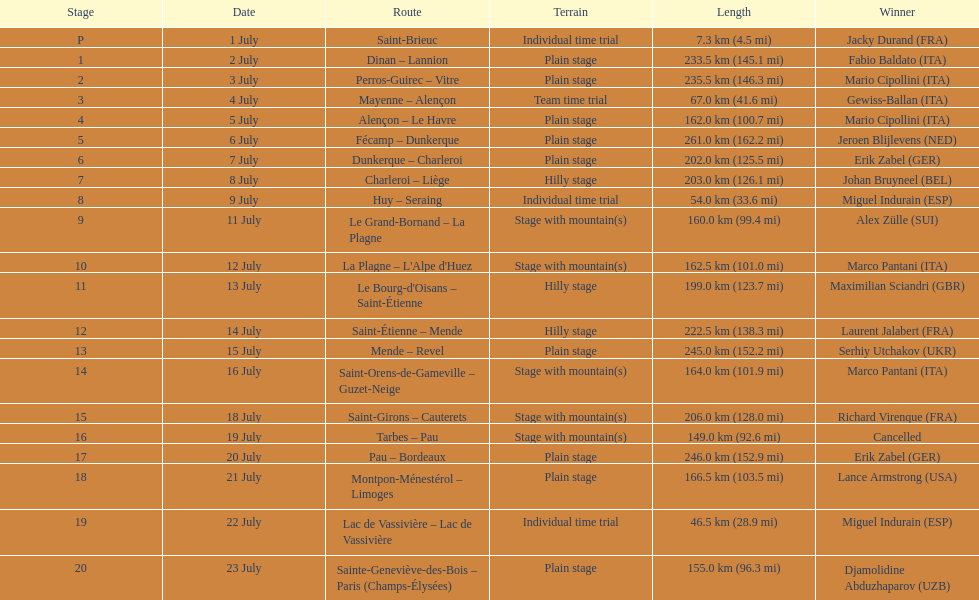Which itineraries covered at least 100 kilometers? Dinan - Lannion, Perros-Guirec - Vitre, Alençon - Le Havre, Fécamp - Dunkerque, Dunkerque - Charleroi, Charleroi - Liège, Le Grand-Bornand - La Plagne, La Plagne - L'Alpe d'Huez, Le Bourg-d'Oisans - Saint-Étienne, Saint-Étienne - Mende, Mende - Revel, Saint-Orens-de-Gameville - Guzet-Neige, Saint-Girons - Cauterets, Tarbes - Pau, Pau - Bordeaux, Montpon-Ménestérol - Limoges, Sainte-Geneviève-des-Bois - Paris (Champs-Élysées). 